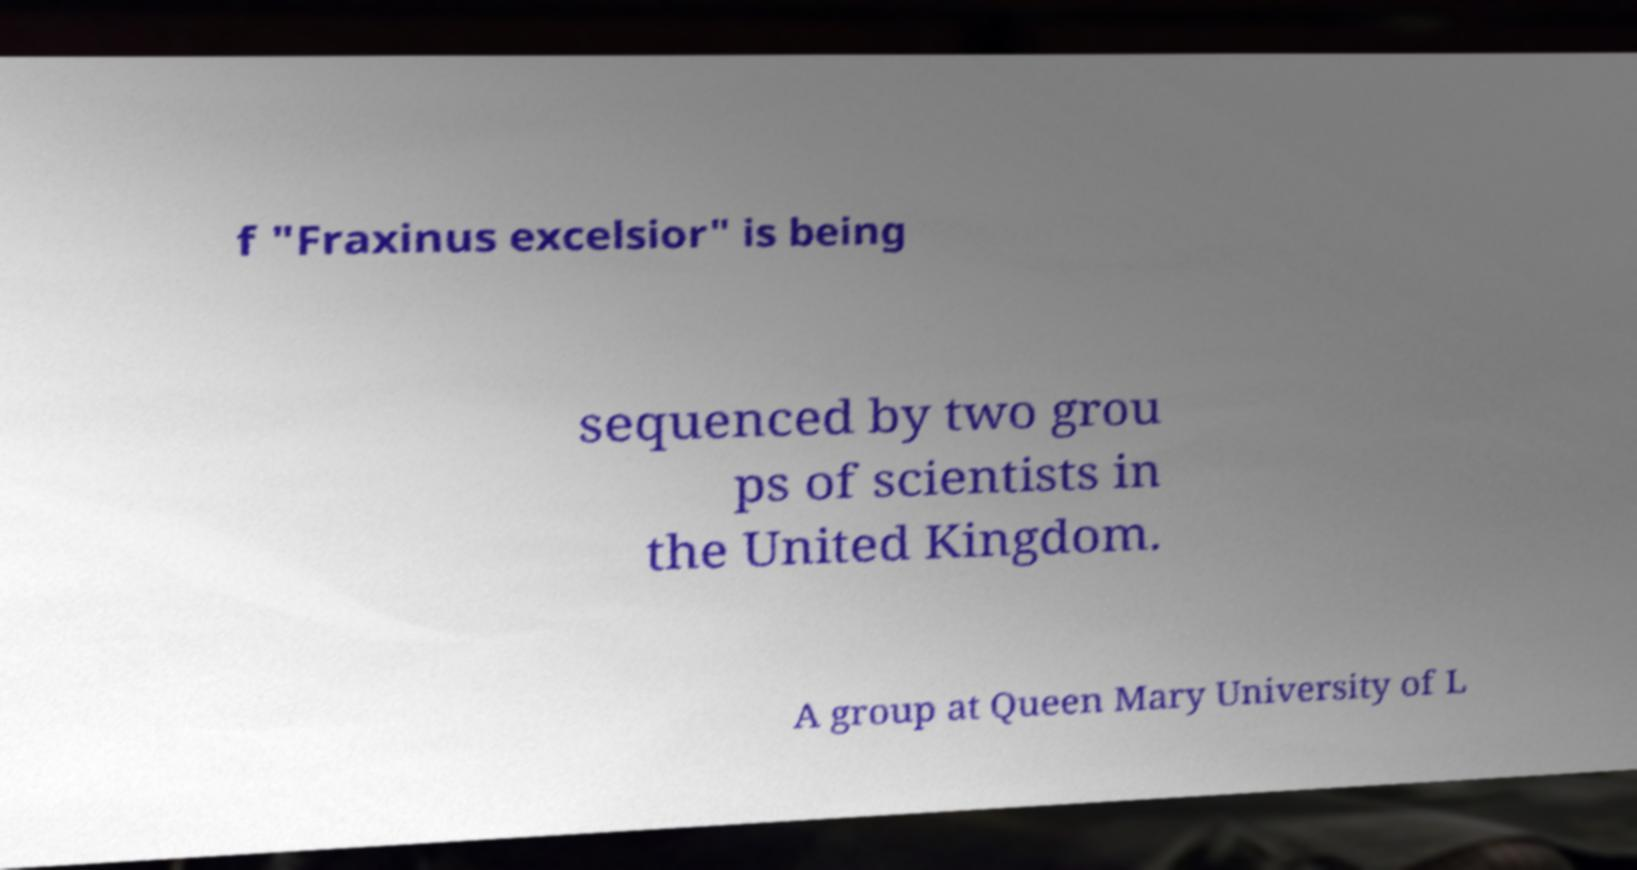What messages or text are displayed in this image? I need them in a readable, typed format. f "Fraxinus excelsior" is being sequenced by two grou ps of scientists in the United Kingdom. A group at Queen Mary University of L 